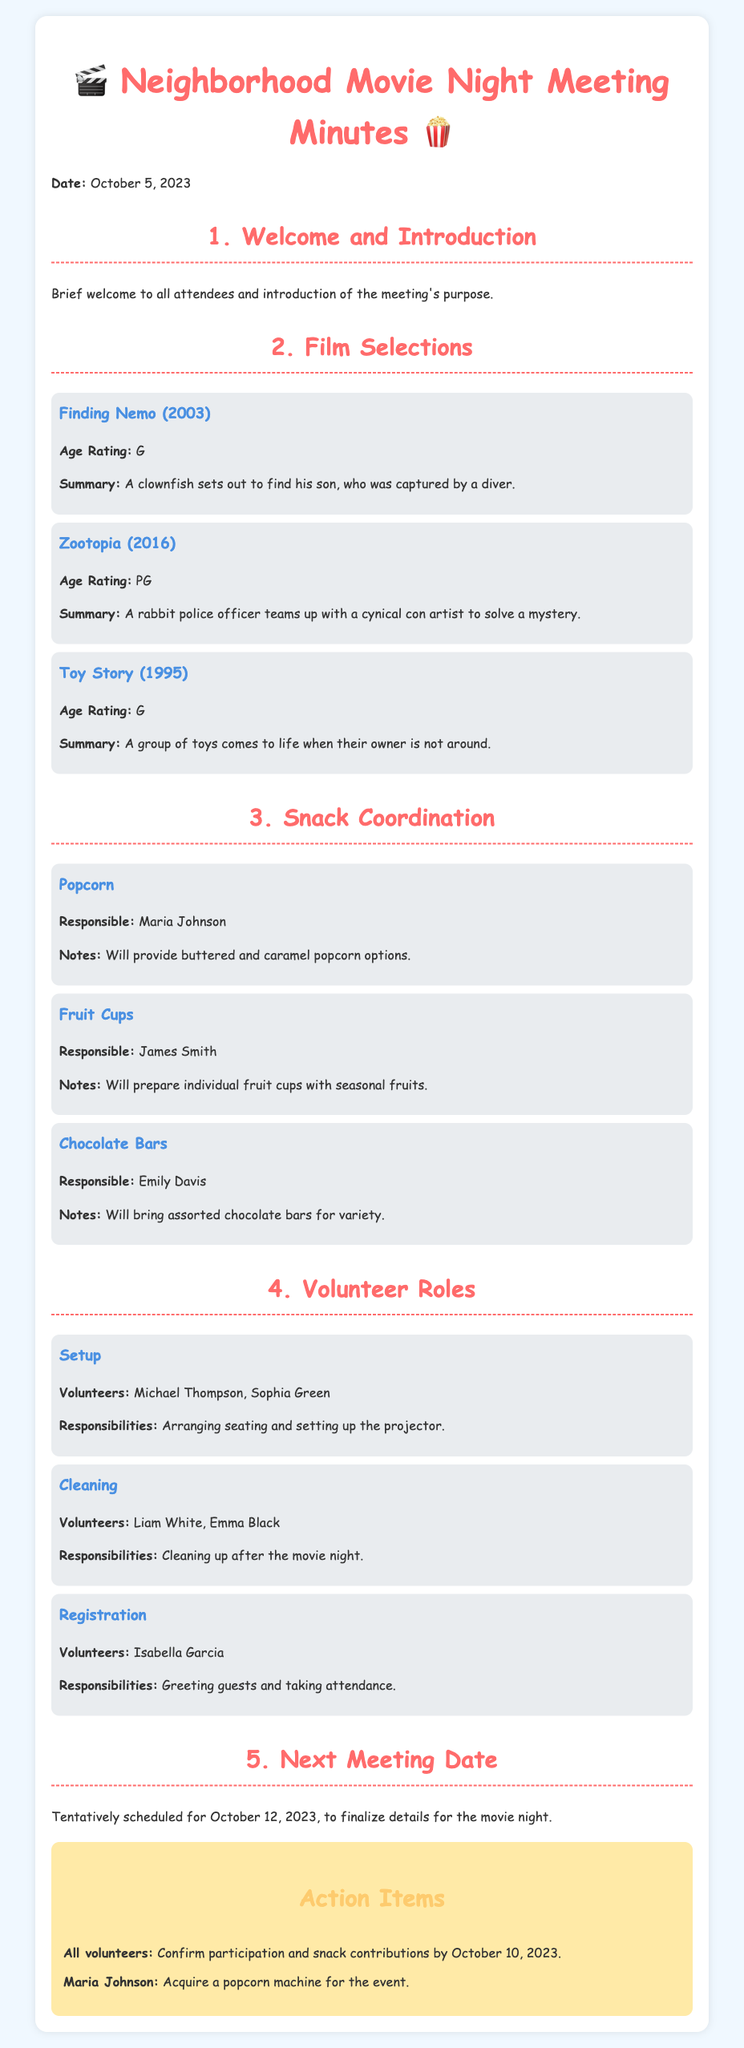What is the date of the meeting? The date of the meeting is stated at the top of the document.
Answer: October 5, 2023 What movies were selected for the movie night? The selected films are listed under the Film Selections section.
Answer: Finding Nemo, Zootopia, Toy Story Who is responsible for popcorn? The responsible person for each snack is mentioned in the Snack Coordination section.
Answer: Maria Johnson What are the responsibilities of the setup volunteers? The responsibilities are outlined in the Volunteer Roles section, specifically for the Setup role.
Answer: Arranging seating and setting up the projector When is the next meeting scheduled? The next meeting date is mentioned towards the end of the document.
Answer: October 12, 2023 How many chocolate bars will Emily Davis bring? The document mentions the types of snacks but not exact quantities.
Answer: Assorted chocolate bars Who is volunteering for cleaning? Volunteers for each role are clearly listed in the Volunteer Roles section.
Answer: Liam White, Emma Black What kind of snack will James Smith prepare? The type of snack he is responsible for is detailed in the Snack Coordination part.
Answer: Fruit Cups 